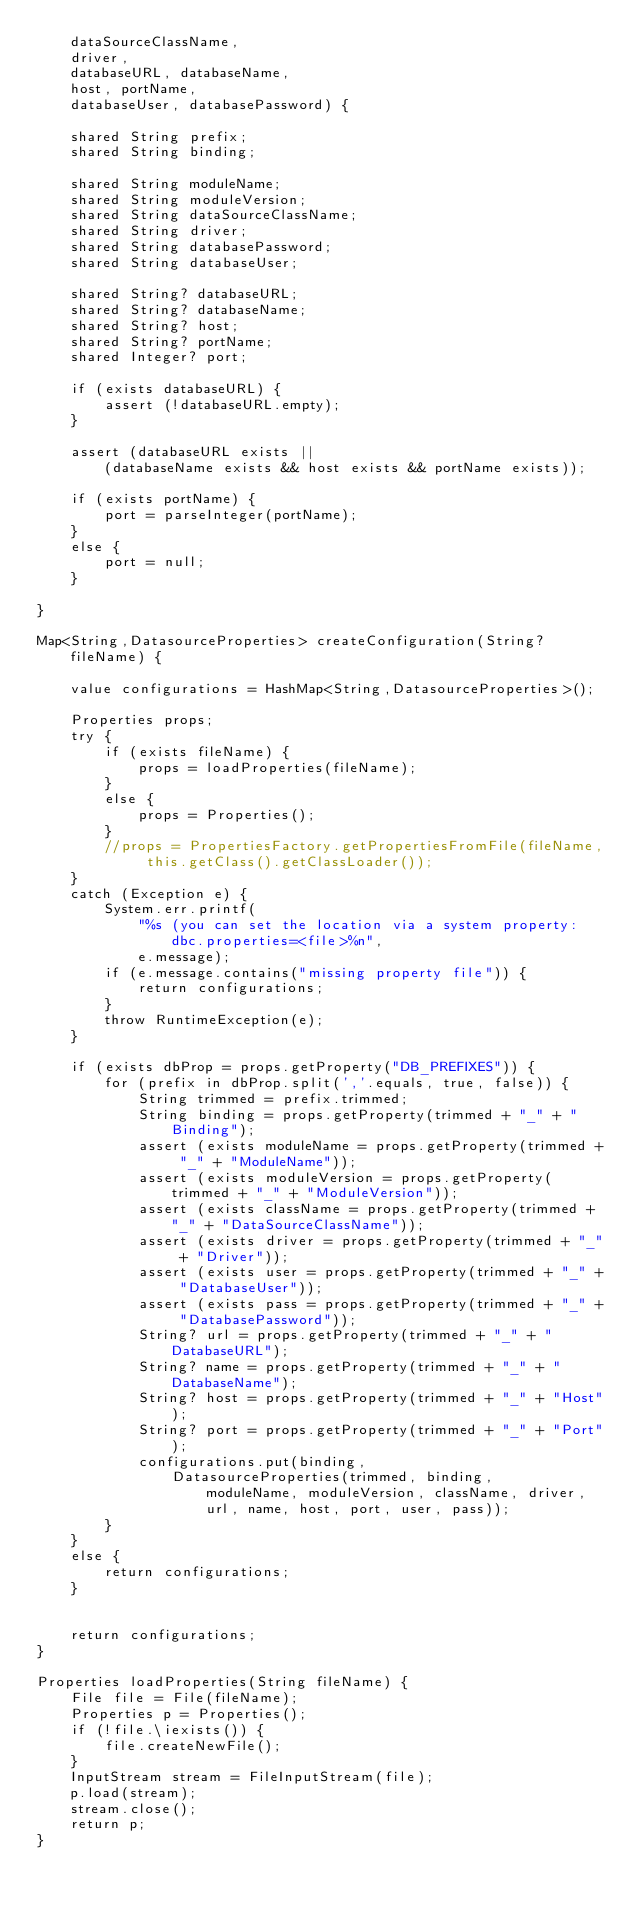<code> <loc_0><loc_0><loc_500><loc_500><_Ceylon_>    dataSourceClassName,
    driver, 
    databaseURL, databaseName,
    host, portName, 
    databaseUser, databasePassword) {
    
    shared String prefix;
    shared String binding;
    
    shared String moduleName;
    shared String moduleVersion;    
    shared String dataSourceClassName;
    shared String driver;
    shared String databasePassword;
    shared String databaseUser;
    
    shared String? databaseURL;
    shared String? databaseName;
    shared String? host;
    shared String? portName;
    shared Integer? port;
    
    if (exists databaseURL) {
        assert (!databaseURL.empty);
    }
    
    assert (databaseURL exists || 
        (databaseName exists && host exists && portName exists));
            
    if (exists portName) {
        port = parseInteger(portName);
    }
    else {
        port = null;
    }

}

Map<String,DatasourceProperties> createConfiguration(String? fileName) {
    
    value configurations = HashMap<String,DatasourceProperties>();
    
    Properties props;
    try {
        if (exists fileName) {
            props = loadProperties(fileName);
        }
        else {
            props = Properties();
        }
        //props = PropertiesFactory.getPropertiesFromFile(fileName, this.getClass().getClassLoader());
    }
    catch (Exception e) {
        System.err.printf(
            "%s (you can set the location via a system property: dbc.properties=<file>%n",
            e.message);
        if (e.message.contains("missing property file")) {
            return configurations;
        }
        throw RuntimeException(e);
    }
    
    if (exists dbProp = props.getProperty("DB_PREFIXES")) {
        for (prefix in dbProp.split(','.equals, true, false)) {
            String trimmed = prefix.trimmed;
            String binding = props.getProperty(trimmed + "_" + "Binding");
            assert (exists moduleName = props.getProperty(trimmed + "_" + "ModuleName"));
            assert (exists moduleVersion = props.getProperty(trimmed + "_" + "ModuleVersion"));
            assert (exists className = props.getProperty(trimmed + "_" + "DataSourceClassName"));
            assert (exists driver = props.getProperty(trimmed + "_" + "Driver"));
            assert (exists user = props.getProperty(trimmed + "_" + "DatabaseUser"));
            assert (exists pass = props.getProperty(trimmed + "_" + "DatabasePassword"));
            String? url = props.getProperty(trimmed + "_" + "DatabaseURL");
            String? name = props.getProperty(trimmed + "_" + "DatabaseName");
            String? host = props.getProperty(trimmed + "_" + "Host");
            String? port = props.getProperty(trimmed + "_" + "Port");
            configurations.put(binding, 
                DatasourceProperties(trimmed, binding,
                    moduleName, moduleVersion, className, driver,
                    url, name, host, port, user, pass));
        }
    }
    else {
        return configurations;
    }
    
    
    return configurations;
}

Properties loadProperties(String fileName) {
    File file = File(fileName);
    Properties p = Properties();
    if (!file.\iexists()) {
        file.createNewFile();
    }
    InputStream stream = FileInputStream(file);
    p.load(stream);
    stream.close();
    return p;
}
</code> 